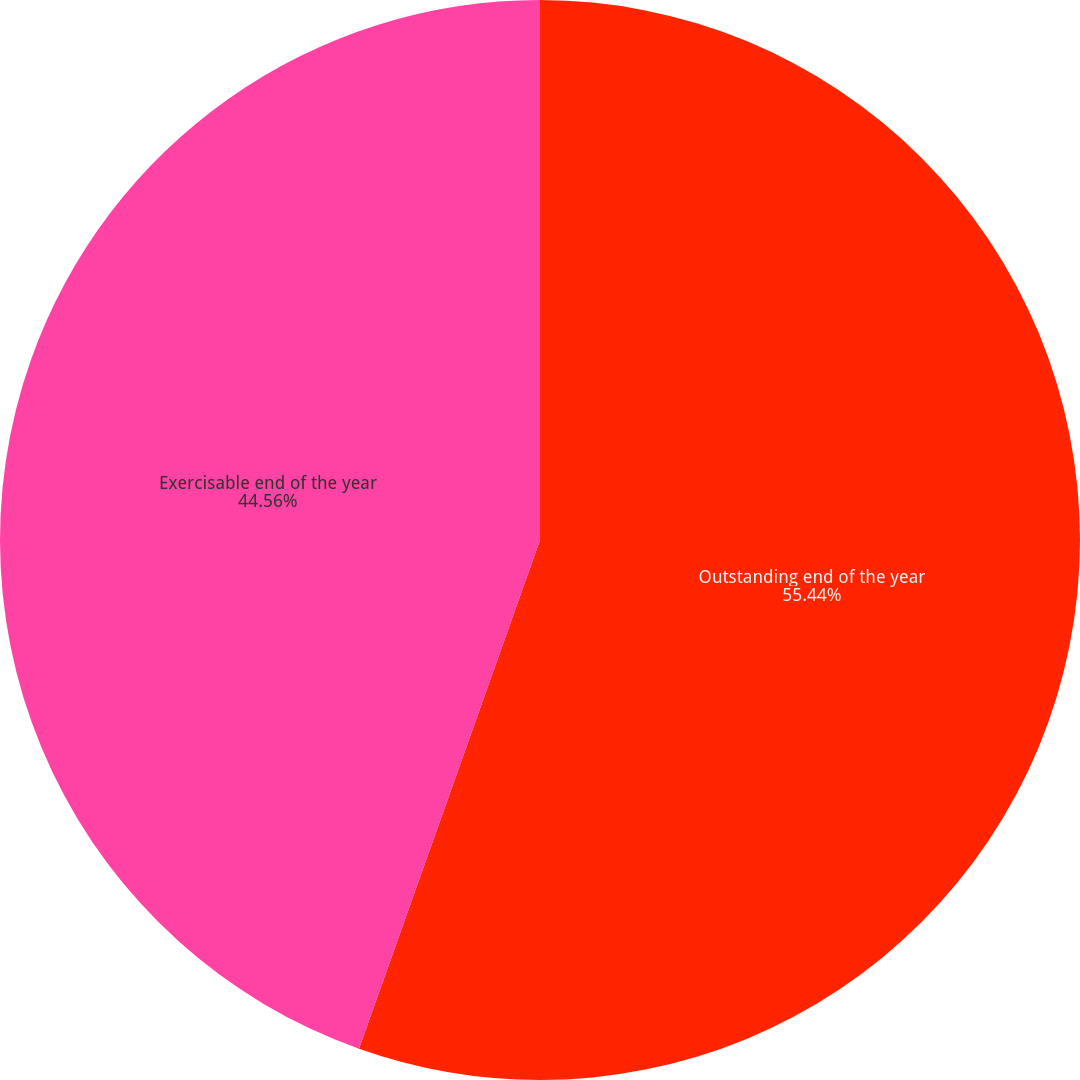<chart> <loc_0><loc_0><loc_500><loc_500><pie_chart><fcel>Outstanding end of the year<fcel>Exercisable end of the year<nl><fcel>55.44%<fcel>44.56%<nl></chart> 